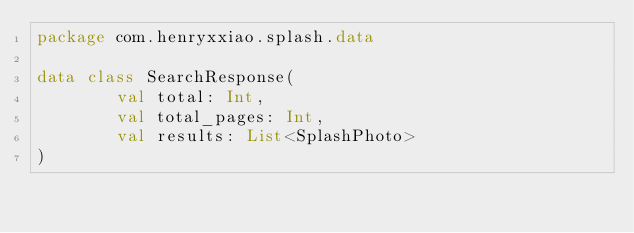Convert code to text. <code><loc_0><loc_0><loc_500><loc_500><_Kotlin_>package com.henryxxiao.splash.data

data class SearchResponse(
        val total: Int,
        val total_pages: Int,
        val results: List<SplashPhoto>
)</code> 